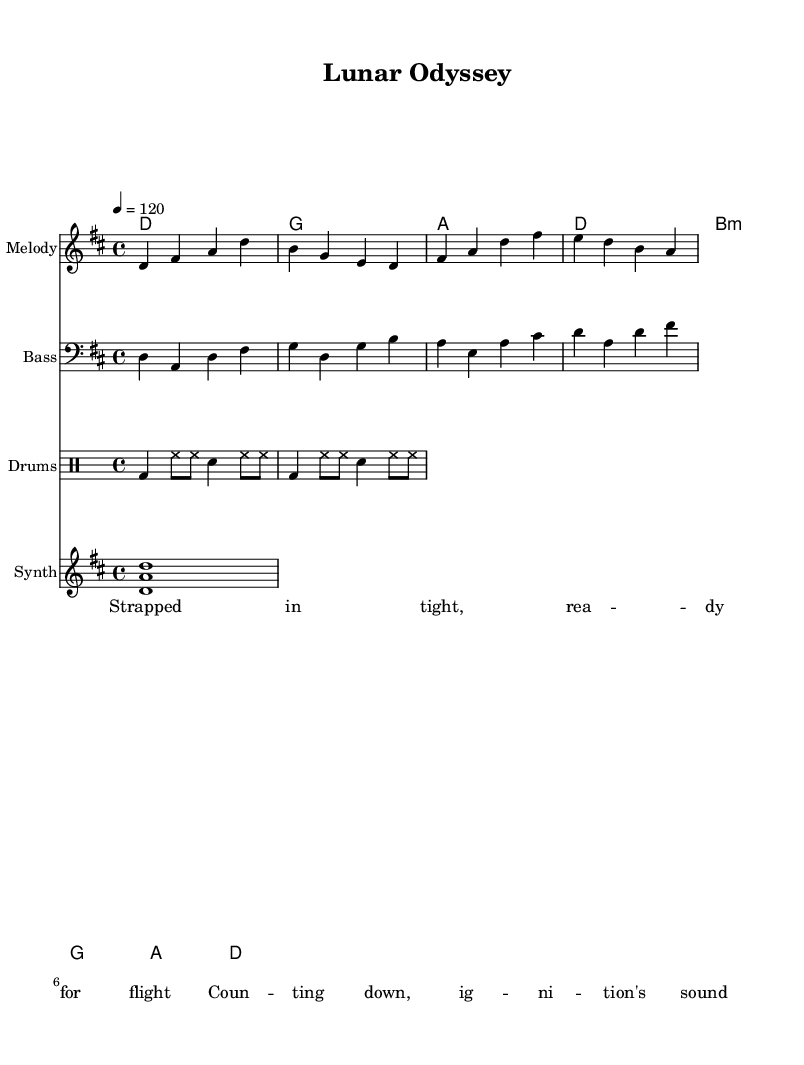What is the key signature of this music? The key signature is D major, which includes two sharps: F sharp and C sharp. This can be identified in the beginning of the staff where the sharps are indicated.
Answer: D major What is the time signature of this music? The time signature is 4/4, which is indicated right after the key signature. In 4/4 time, there are four beats per measure, and the quarter note gets one beat.
Answer: 4/4 What is the tempo marking for this piece? The tempo marking is 120 beats per minute. This is shown in the tempo indication found at the beginning, specifying the speed of the piece.
Answer: 120 How many measures are there in the melody? There are four measures in the melody. By counting the groupings of notes within the staff, you can see that they are organized into four separate measures.
Answer: 4 What chords are used in the chord progression? The chords used are D, G, A, and B minor. These chord names are listed above the staff, correlating with the respective measures in the melody.
Answer: D, G, A, B minor How many notes are in the bass line? There are twelve notes in the bass line. By counting each note in the provided bass line section, we find a total of twelve distinct pitches.
Answer: 12 What type of drum pattern is indicated in the drumming part? The drum pattern uses a combination of bass drums, hi-hats, and snare drums. This can be analyzed by looking at the specific notation in the drummode section, which includes different symbols for each type of drum.
Answer: Bass, hi-hat, snare 